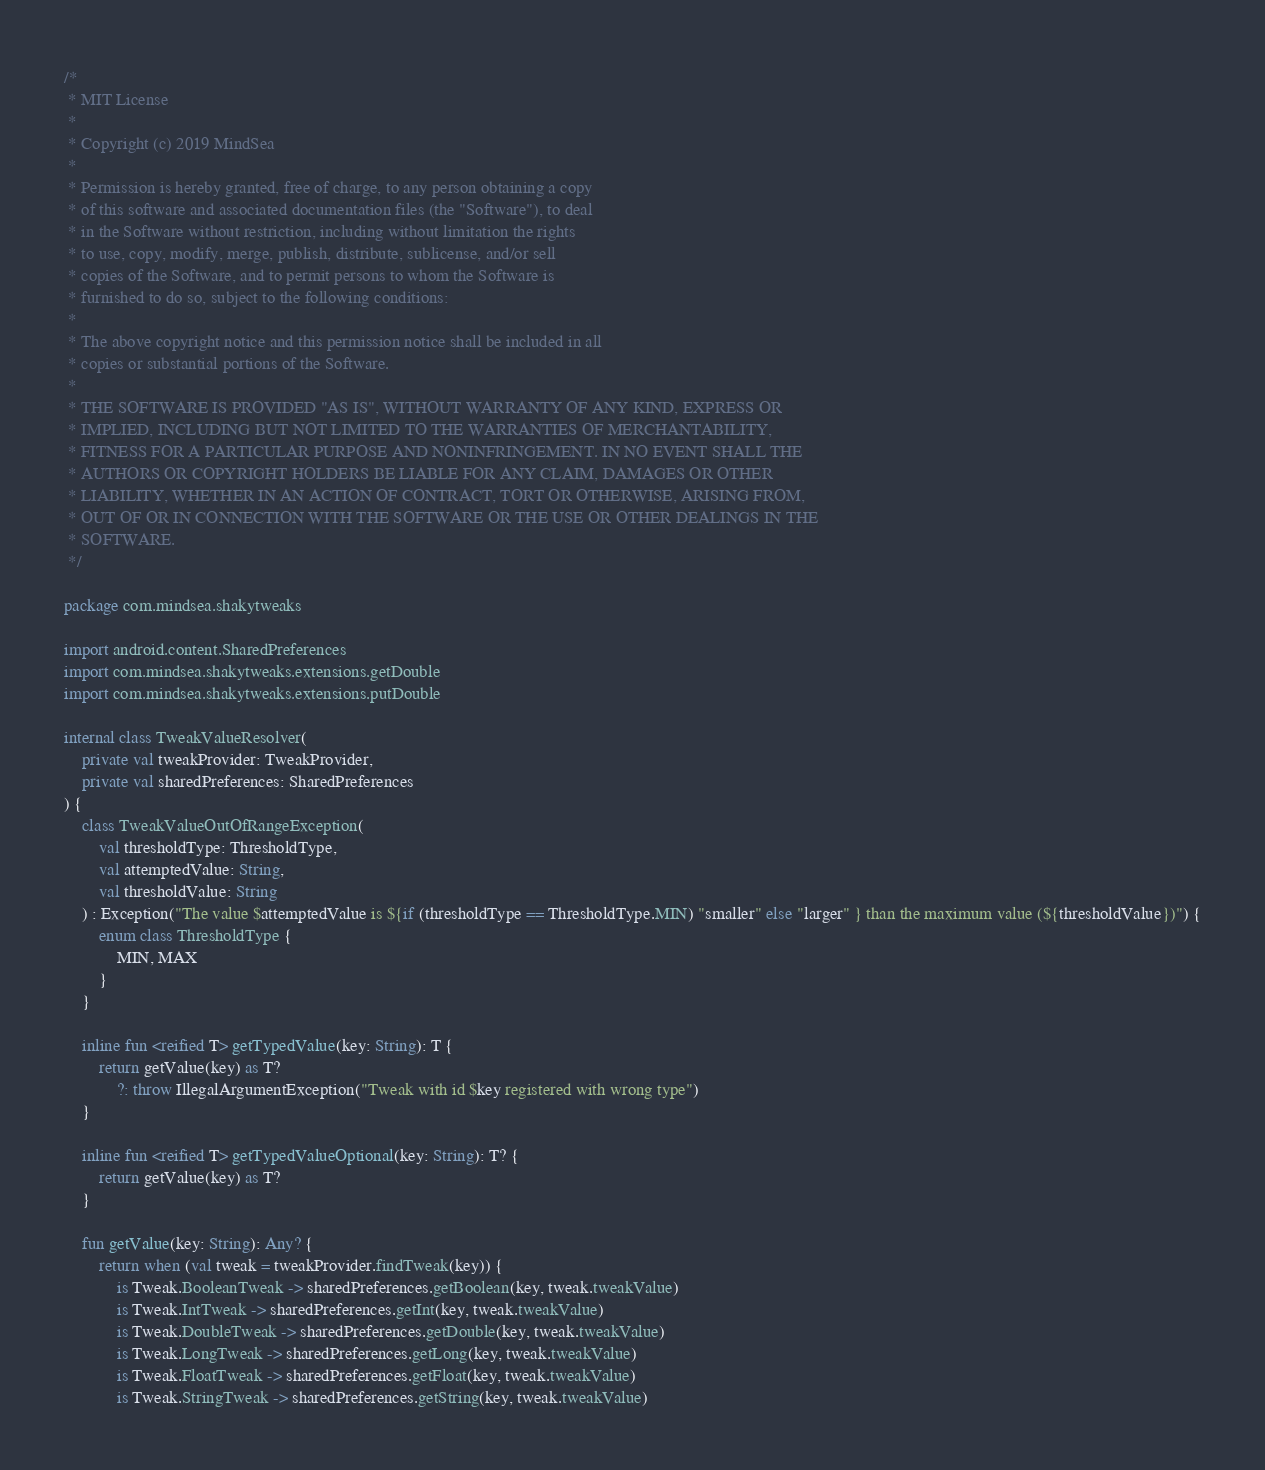Convert code to text. <code><loc_0><loc_0><loc_500><loc_500><_Kotlin_>/*
 * MIT License
 *
 * Copyright (c) 2019 MindSea
 *
 * Permission is hereby granted, free of charge, to any person obtaining a copy
 * of this software and associated documentation files (the "Software"), to deal
 * in the Software without restriction, including without limitation the rights
 * to use, copy, modify, merge, publish, distribute, sublicense, and/or sell
 * copies of the Software, and to permit persons to whom the Software is
 * furnished to do so, subject to the following conditions:
 *
 * The above copyright notice and this permission notice shall be included in all
 * copies or substantial portions of the Software.
 *
 * THE SOFTWARE IS PROVIDED "AS IS", WITHOUT WARRANTY OF ANY KIND, EXPRESS OR
 * IMPLIED, INCLUDING BUT NOT LIMITED TO THE WARRANTIES OF MERCHANTABILITY,
 * FITNESS FOR A PARTICULAR PURPOSE AND NONINFRINGEMENT. IN NO EVENT SHALL THE
 * AUTHORS OR COPYRIGHT HOLDERS BE LIABLE FOR ANY CLAIM, DAMAGES OR OTHER
 * LIABILITY, WHETHER IN AN ACTION OF CONTRACT, TORT OR OTHERWISE, ARISING FROM,
 * OUT OF OR IN CONNECTION WITH THE SOFTWARE OR THE USE OR OTHER DEALINGS IN THE
 * SOFTWARE.
 */

package com.mindsea.shakytweaks

import android.content.SharedPreferences
import com.mindsea.shakytweaks.extensions.getDouble
import com.mindsea.shakytweaks.extensions.putDouble

internal class TweakValueResolver(
    private val tweakProvider: TweakProvider,
    private val sharedPreferences: SharedPreferences
) {
    class TweakValueOutOfRangeException(
        val thresholdType: ThresholdType,
        val attemptedValue: String,
        val thresholdValue: String
    ) : Exception("The value $attemptedValue is ${if (thresholdType == ThresholdType.MIN) "smaller" else "larger" } than the maximum value (${thresholdValue})") {
        enum class ThresholdType {
            MIN, MAX
        }
    }

    inline fun <reified T> getTypedValue(key: String): T {
        return getValue(key) as T?
            ?: throw IllegalArgumentException("Tweak with id $key registered with wrong type")
    }

    inline fun <reified T> getTypedValueOptional(key: String): T? {
        return getValue(key) as T?
    }

    fun getValue(key: String): Any? {
        return when (val tweak = tweakProvider.findTweak(key)) {
            is Tweak.BooleanTweak -> sharedPreferences.getBoolean(key, tweak.tweakValue)
            is Tweak.IntTweak -> sharedPreferences.getInt(key, tweak.tweakValue)
            is Tweak.DoubleTweak -> sharedPreferences.getDouble(key, tweak.tweakValue)
            is Tweak.LongTweak -> sharedPreferences.getLong(key, tweak.tweakValue)
            is Tweak.FloatTweak -> sharedPreferences.getFloat(key, tweak.tweakValue)
            is Tweak.StringTweak -> sharedPreferences.getString(key, tweak.tweakValue)</code> 